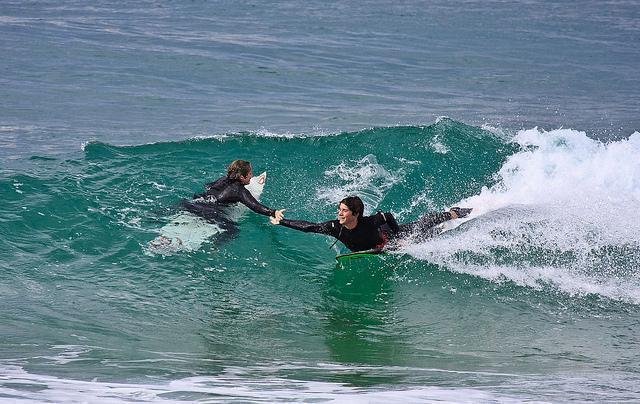What are the people holding?
Select the accurate answer and provide explanation: 'Answer: answer
Rationale: rationale.'
Options: Diapers, babies, bats, hands. Answer: hands.
Rationale: The people in the waves are holding hands. 